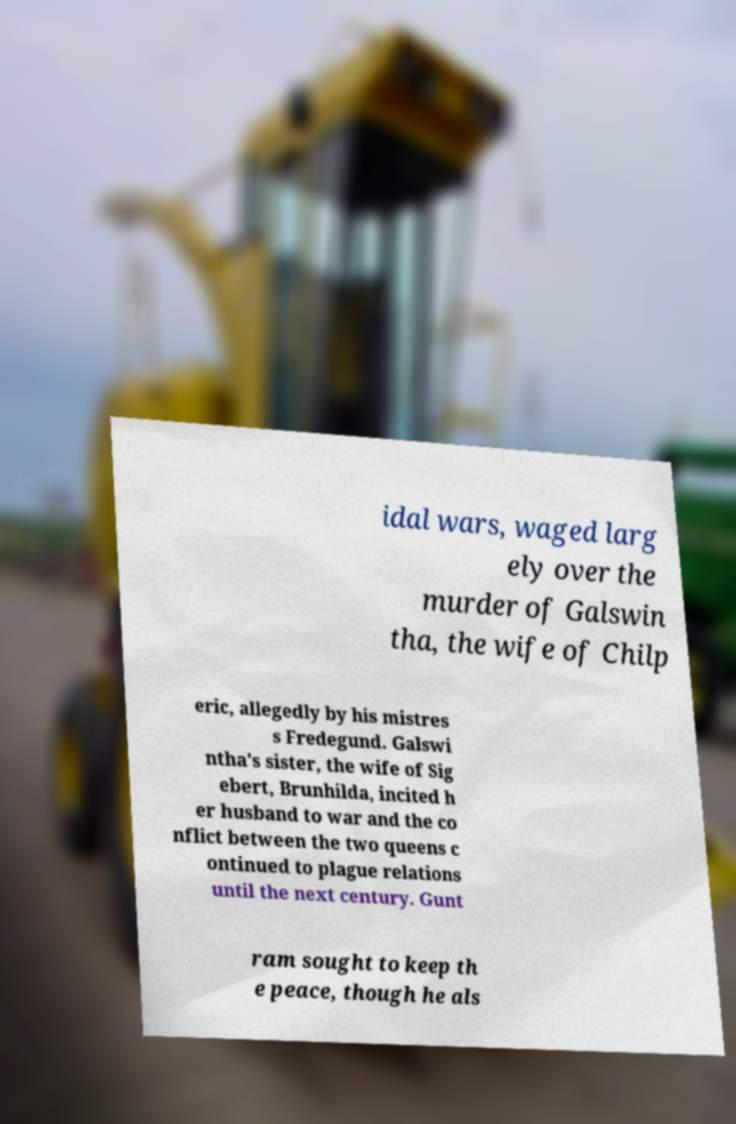Could you assist in decoding the text presented in this image and type it out clearly? idal wars, waged larg ely over the murder of Galswin tha, the wife of Chilp eric, allegedly by his mistres s Fredegund. Galswi ntha's sister, the wife of Sig ebert, Brunhilda, incited h er husband to war and the co nflict between the two queens c ontinued to plague relations until the next century. Gunt ram sought to keep th e peace, though he als 